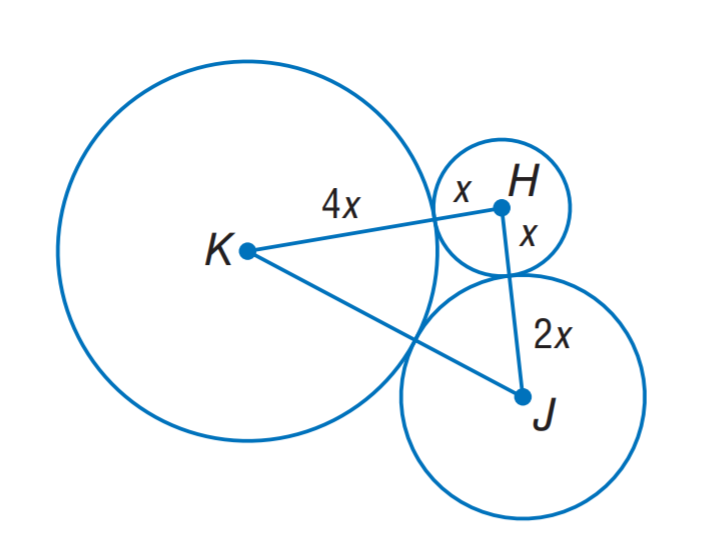Answer the mathemtical geometry problem and directly provide the correct option letter.
Question: The sum of the circumference of circles H, J, K is 56 \pi units. Find K J.
Choices: A: 12 B: 24 C: 28 D: 56 B 